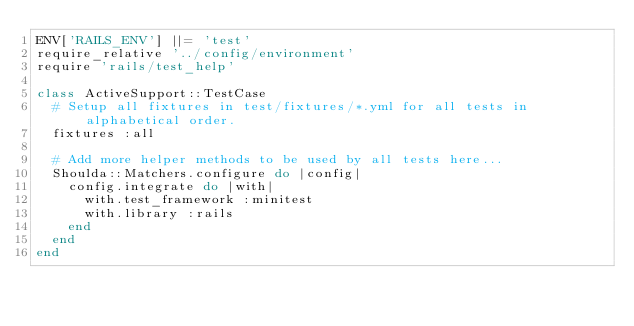Convert code to text. <code><loc_0><loc_0><loc_500><loc_500><_Ruby_>ENV['RAILS_ENV'] ||= 'test'
require_relative '../config/environment'
require 'rails/test_help'

class ActiveSupport::TestCase
  # Setup all fixtures in test/fixtures/*.yml for all tests in alphabetical order.
  fixtures :all

  # Add more helper methods to be used by all tests here...
  Shoulda::Matchers.configure do |config|
    config.integrate do |with|
      with.test_framework :minitest
      with.library :rails
    end
  end
end
</code> 